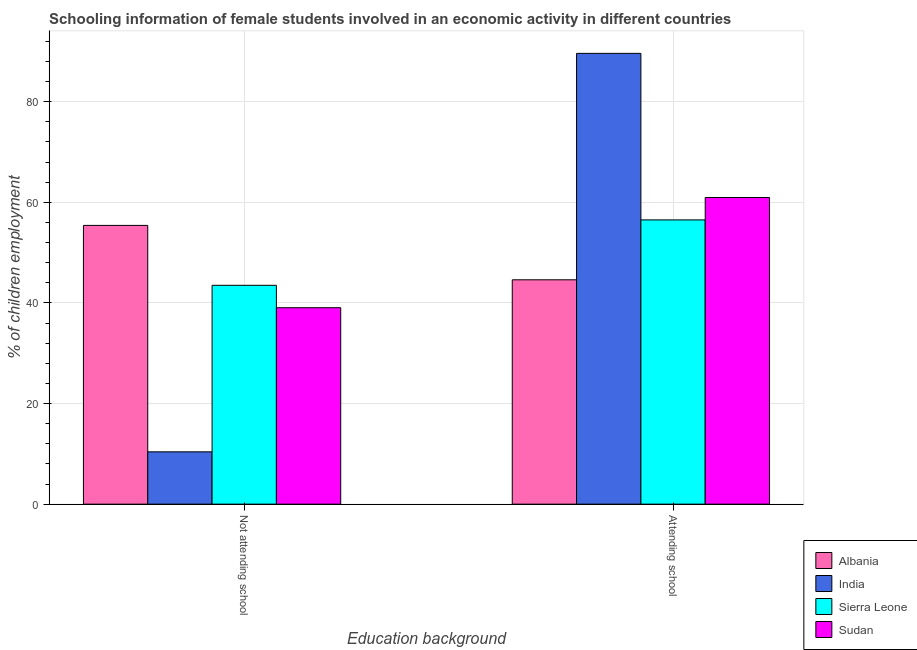How many different coloured bars are there?
Your response must be concise. 4. How many groups of bars are there?
Your response must be concise. 2. What is the label of the 1st group of bars from the left?
Give a very brief answer. Not attending school. What is the percentage of employed females who are attending school in India?
Provide a short and direct response. 89.6. Across all countries, what is the maximum percentage of employed females who are not attending school?
Provide a short and direct response. 55.41. Across all countries, what is the minimum percentage of employed females who are attending school?
Your answer should be compact. 44.59. In which country was the percentage of employed females who are attending school maximum?
Offer a terse response. India. In which country was the percentage of employed females who are attending school minimum?
Provide a short and direct response. Albania. What is the total percentage of employed females who are not attending school in the graph?
Offer a terse response. 148.35. What is the difference between the percentage of employed females who are not attending school in Sierra Leone and that in Sudan?
Your response must be concise. 4.45. What is the difference between the percentage of employed females who are not attending school in Sierra Leone and the percentage of employed females who are attending school in India?
Your answer should be very brief. -46.1. What is the average percentage of employed females who are not attending school per country?
Your answer should be compact. 37.09. What is the difference between the percentage of employed females who are attending school and percentage of employed females who are not attending school in India?
Give a very brief answer. 79.2. In how many countries, is the percentage of employed females who are attending school greater than 32 %?
Ensure brevity in your answer.  4. What is the ratio of the percentage of employed females who are not attending school in India to that in Sierra Leone?
Make the answer very short. 0.24. Is the percentage of employed females who are attending school in Sudan less than that in India?
Your response must be concise. Yes. In how many countries, is the percentage of employed females who are attending school greater than the average percentage of employed females who are attending school taken over all countries?
Provide a short and direct response. 1. What does the 1st bar from the left in Attending school represents?
Keep it short and to the point. Albania. What does the 1st bar from the right in Not attending school represents?
Your response must be concise. Sudan. How many countries are there in the graph?
Your response must be concise. 4. What is the difference between two consecutive major ticks on the Y-axis?
Offer a terse response. 20. Are the values on the major ticks of Y-axis written in scientific E-notation?
Your answer should be very brief. No. Does the graph contain grids?
Give a very brief answer. Yes. How are the legend labels stacked?
Keep it short and to the point. Vertical. What is the title of the graph?
Ensure brevity in your answer.  Schooling information of female students involved in an economic activity in different countries. What is the label or title of the X-axis?
Provide a short and direct response. Education background. What is the label or title of the Y-axis?
Your answer should be compact. % of children employment. What is the % of children employment of Albania in Not attending school?
Provide a succinct answer. 55.41. What is the % of children employment in India in Not attending school?
Provide a succinct answer. 10.4. What is the % of children employment of Sierra Leone in Not attending school?
Your answer should be very brief. 43.5. What is the % of children employment of Sudan in Not attending school?
Provide a succinct answer. 39.05. What is the % of children employment in Albania in Attending school?
Give a very brief answer. 44.59. What is the % of children employment in India in Attending school?
Provide a short and direct response. 89.6. What is the % of children employment in Sierra Leone in Attending school?
Your answer should be very brief. 56.5. What is the % of children employment in Sudan in Attending school?
Provide a succinct answer. 60.95. Across all Education background, what is the maximum % of children employment in Albania?
Make the answer very short. 55.41. Across all Education background, what is the maximum % of children employment of India?
Provide a short and direct response. 89.6. Across all Education background, what is the maximum % of children employment of Sierra Leone?
Your answer should be very brief. 56.5. Across all Education background, what is the maximum % of children employment of Sudan?
Provide a succinct answer. 60.95. Across all Education background, what is the minimum % of children employment of Albania?
Your answer should be very brief. 44.59. Across all Education background, what is the minimum % of children employment in India?
Your answer should be compact. 10.4. Across all Education background, what is the minimum % of children employment in Sierra Leone?
Ensure brevity in your answer.  43.5. Across all Education background, what is the minimum % of children employment of Sudan?
Your response must be concise. 39.05. What is the total % of children employment in Sudan in the graph?
Your answer should be very brief. 100. What is the difference between the % of children employment of Albania in Not attending school and that in Attending school?
Keep it short and to the point. 10.81. What is the difference between the % of children employment in India in Not attending school and that in Attending school?
Your answer should be compact. -79.2. What is the difference between the % of children employment of Sierra Leone in Not attending school and that in Attending school?
Keep it short and to the point. -13. What is the difference between the % of children employment in Sudan in Not attending school and that in Attending school?
Provide a succinct answer. -21.91. What is the difference between the % of children employment of Albania in Not attending school and the % of children employment of India in Attending school?
Your answer should be compact. -34.19. What is the difference between the % of children employment in Albania in Not attending school and the % of children employment in Sierra Leone in Attending school?
Offer a terse response. -1.09. What is the difference between the % of children employment of Albania in Not attending school and the % of children employment of Sudan in Attending school?
Your answer should be compact. -5.55. What is the difference between the % of children employment of India in Not attending school and the % of children employment of Sierra Leone in Attending school?
Your response must be concise. -46.1. What is the difference between the % of children employment of India in Not attending school and the % of children employment of Sudan in Attending school?
Keep it short and to the point. -50.55. What is the difference between the % of children employment of Sierra Leone in Not attending school and the % of children employment of Sudan in Attending school?
Your response must be concise. -17.45. What is the average % of children employment of Albania per Education background?
Provide a short and direct response. 50. What is the average % of children employment of India per Education background?
Offer a very short reply. 50. What is the difference between the % of children employment of Albania and % of children employment of India in Not attending school?
Your answer should be compact. 45.01. What is the difference between the % of children employment of Albania and % of children employment of Sierra Leone in Not attending school?
Offer a terse response. 11.91. What is the difference between the % of children employment in Albania and % of children employment in Sudan in Not attending school?
Make the answer very short. 16.36. What is the difference between the % of children employment of India and % of children employment of Sierra Leone in Not attending school?
Offer a very short reply. -33.1. What is the difference between the % of children employment in India and % of children employment in Sudan in Not attending school?
Give a very brief answer. -28.65. What is the difference between the % of children employment in Sierra Leone and % of children employment in Sudan in Not attending school?
Keep it short and to the point. 4.45. What is the difference between the % of children employment of Albania and % of children employment of India in Attending school?
Your response must be concise. -45.01. What is the difference between the % of children employment in Albania and % of children employment in Sierra Leone in Attending school?
Give a very brief answer. -11.91. What is the difference between the % of children employment of Albania and % of children employment of Sudan in Attending school?
Make the answer very short. -16.36. What is the difference between the % of children employment of India and % of children employment of Sierra Leone in Attending school?
Your response must be concise. 33.1. What is the difference between the % of children employment of India and % of children employment of Sudan in Attending school?
Offer a terse response. 28.65. What is the difference between the % of children employment of Sierra Leone and % of children employment of Sudan in Attending school?
Your answer should be compact. -4.45. What is the ratio of the % of children employment of Albania in Not attending school to that in Attending school?
Offer a very short reply. 1.24. What is the ratio of the % of children employment of India in Not attending school to that in Attending school?
Keep it short and to the point. 0.12. What is the ratio of the % of children employment of Sierra Leone in Not attending school to that in Attending school?
Your answer should be very brief. 0.77. What is the ratio of the % of children employment in Sudan in Not attending school to that in Attending school?
Your answer should be very brief. 0.64. What is the difference between the highest and the second highest % of children employment in Albania?
Provide a short and direct response. 10.81. What is the difference between the highest and the second highest % of children employment in India?
Your answer should be very brief. 79.2. What is the difference between the highest and the second highest % of children employment of Sudan?
Your answer should be compact. 21.91. What is the difference between the highest and the lowest % of children employment in Albania?
Offer a terse response. 10.81. What is the difference between the highest and the lowest % of children employment in India?
Offer a terse response. 79.2. What is the difference between the highest and the lowest % of children employment of Sudan?
Your answer should be compact. 21.91. 